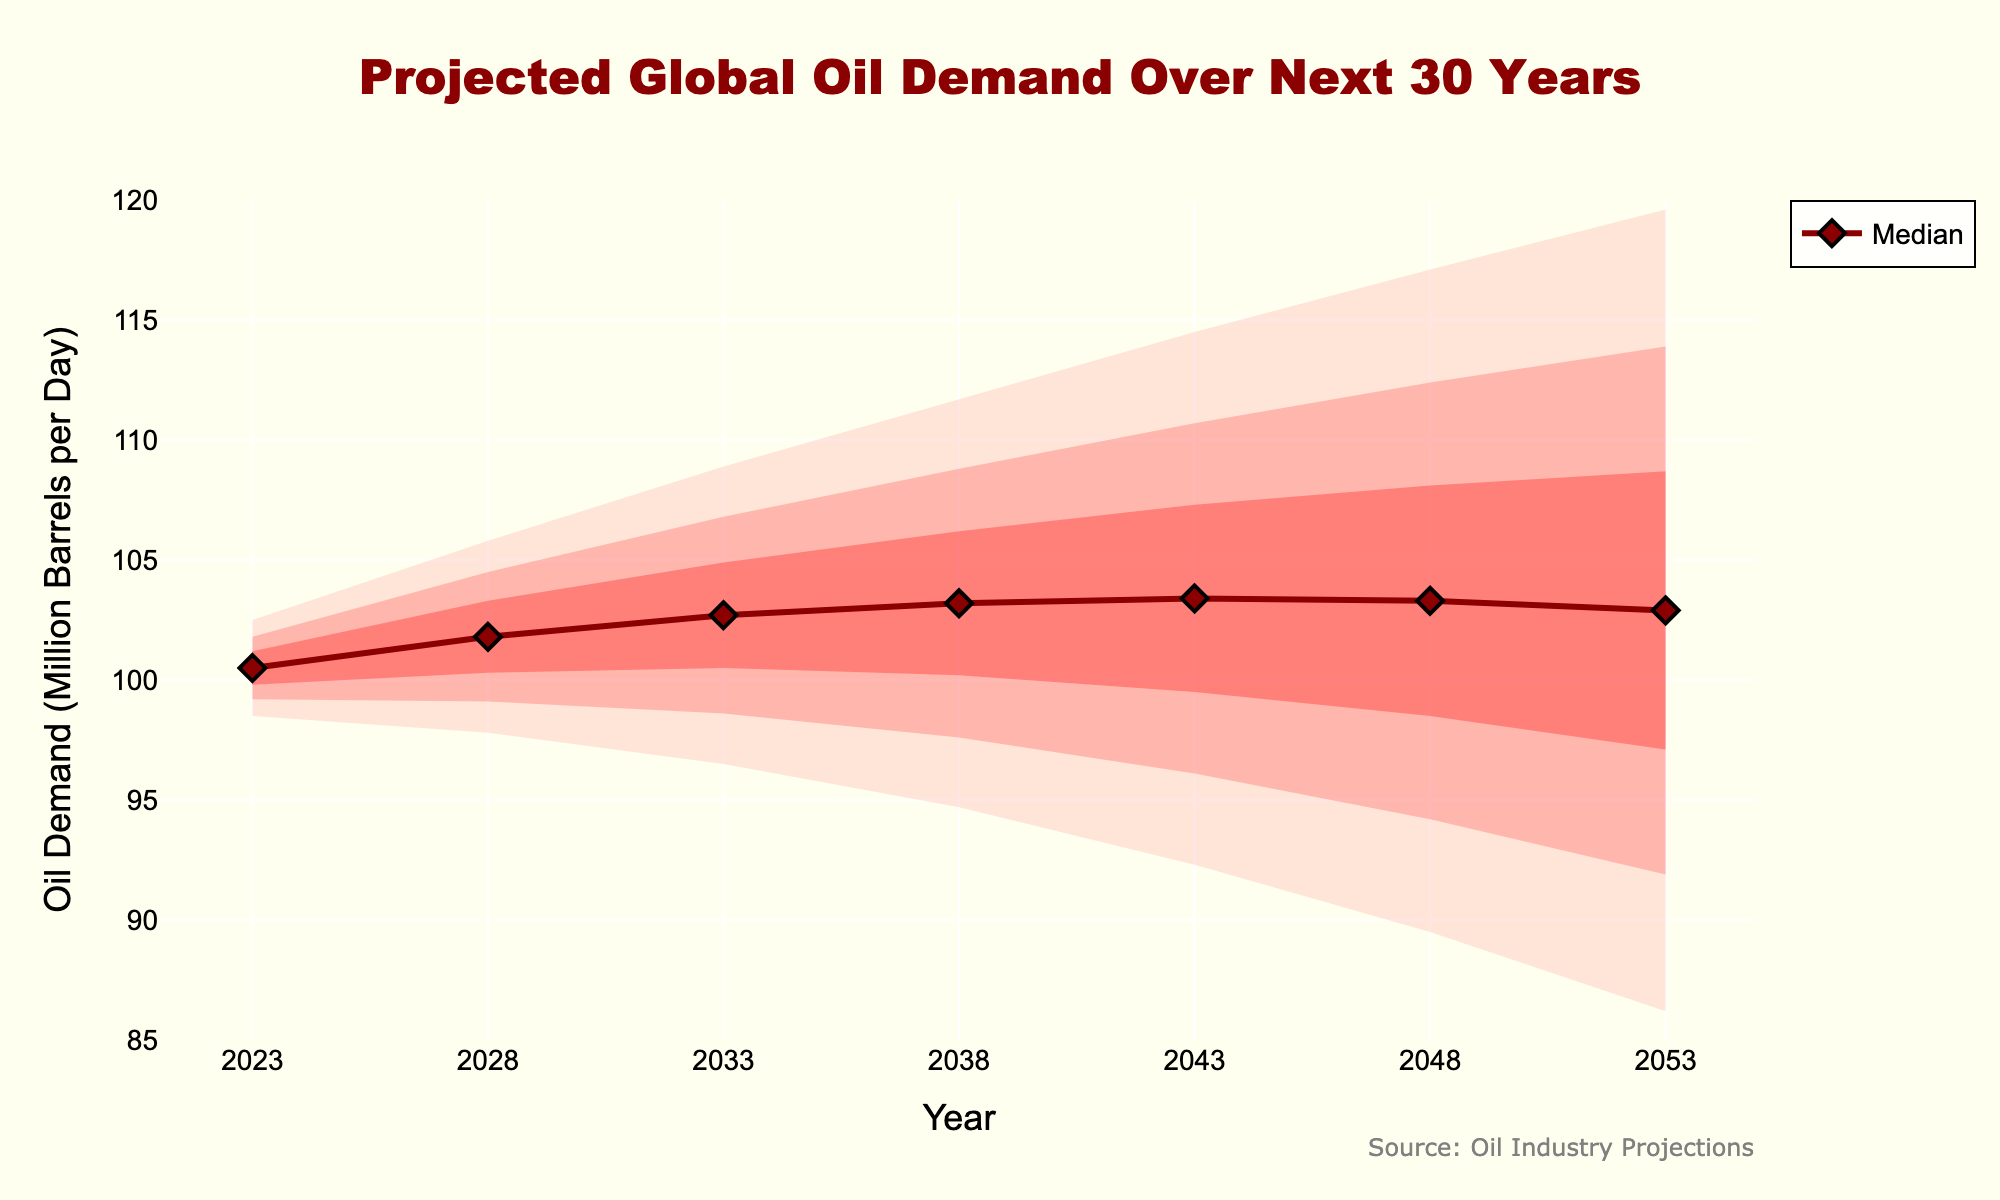What is the median projected global oil demand in 2033? The median value for global oil demand in 2033 can be directly read from the "Median" line on the chart, which is plotted clearly.
Answer: 102.7 million barrels per day What is the difference between the high 60% interval and median oil demand for the year 2053? The high 60% value and median value for the year 2053 can be found in the chart. Subtract the median value from the high 60% value: 108.7 - 102.9.
Answer: 5.8 million barrels per day In which year is the low 80% interval the lowest? To find this, compare the low 80% interval values across all years. The lowest value occurs at the year with the smallest low 80% interval.
Answer: 2053 How does the median oil demand change from 2023 to 2048? Find the median values for the years 2023 and 2048 from the chart. The change is the difference between these values: 103.3 - 100.5.
Answer: It increases by 2.8 million barrels per day Which year shows the highest oil demand in the high 95% confidence interval? To determine this, compare the high 95% values for all years in the chart. The highest value will indicate the year with the highest projected demand.
Answer: 2053 By how much does the low 95% interval drop from 2023 to 2043? Determine the low 95% values for the years 2023 and 2043 and calculate the difference: 98.5 - 92.3.
Answer: 6.2 million barrels per day What is the range of oil demand in the year 2028 within the 80% confidence interval? The 80% confidence interval range is found by subtracting the low 80% value from the high 80% value in 2028: 104.5 - 99.1.
Answer: 5.4 million barrels per day How does the trend of the median oil demand look over the years? Analyze the median values across all the years to see if it is increasing, decreasing, or staying constant.
Answer: Increasing Which confidence interval is the widest in 2053? Compare the width of the intervals (High - Low) for each percentage in 2053. The interval with the largest width will be the widest.
Answer: 95% How much does the high 60% interval increase from 2038 to 2048? Calculate the difference in the 60% interval highs between 2048 and 2038: 108.1 - 106.2.
Answer: 1.9 million barrels per day 